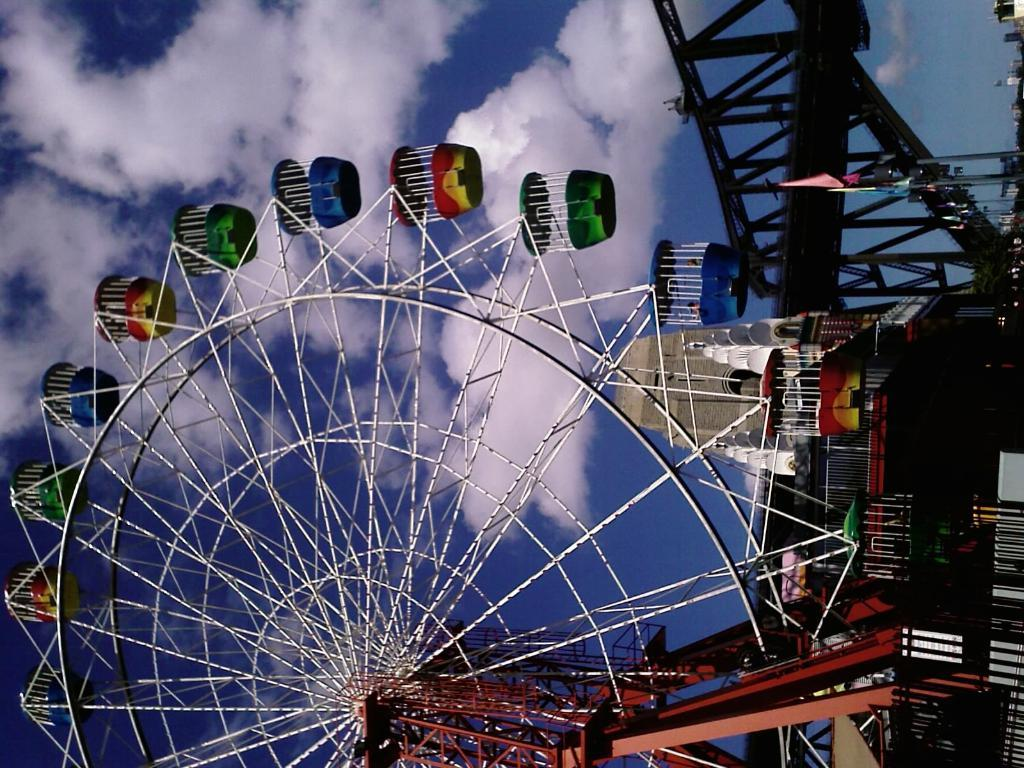How is the orientation of the image? The image is rotated. What type of wheel can be seen in the image? There is a joint wheel in the image. What material is the structure in the image made of? The structure in the image is made of metal. What can be seen in the background of the image? The sky is visible in the background of the image. What time is displayed on the watch in the image? There is no watch present in the image. How does the moon appear to be twisting in the image? The image does not contain a moon, and therefore there is no twisting moon to observe. 